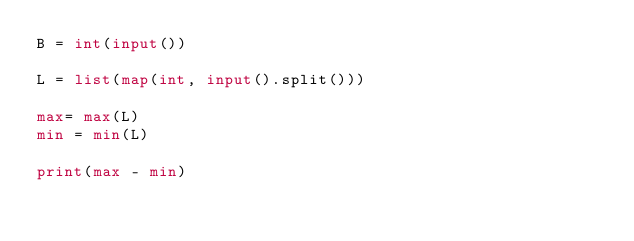Convert code to text. <code><loc_0><loc_0><loc_500><loc_500><_Python_>B = int(input())

L = list(map(int, input().split()))

max= max(L)
min = min(L)

print(max - min)
</code> 